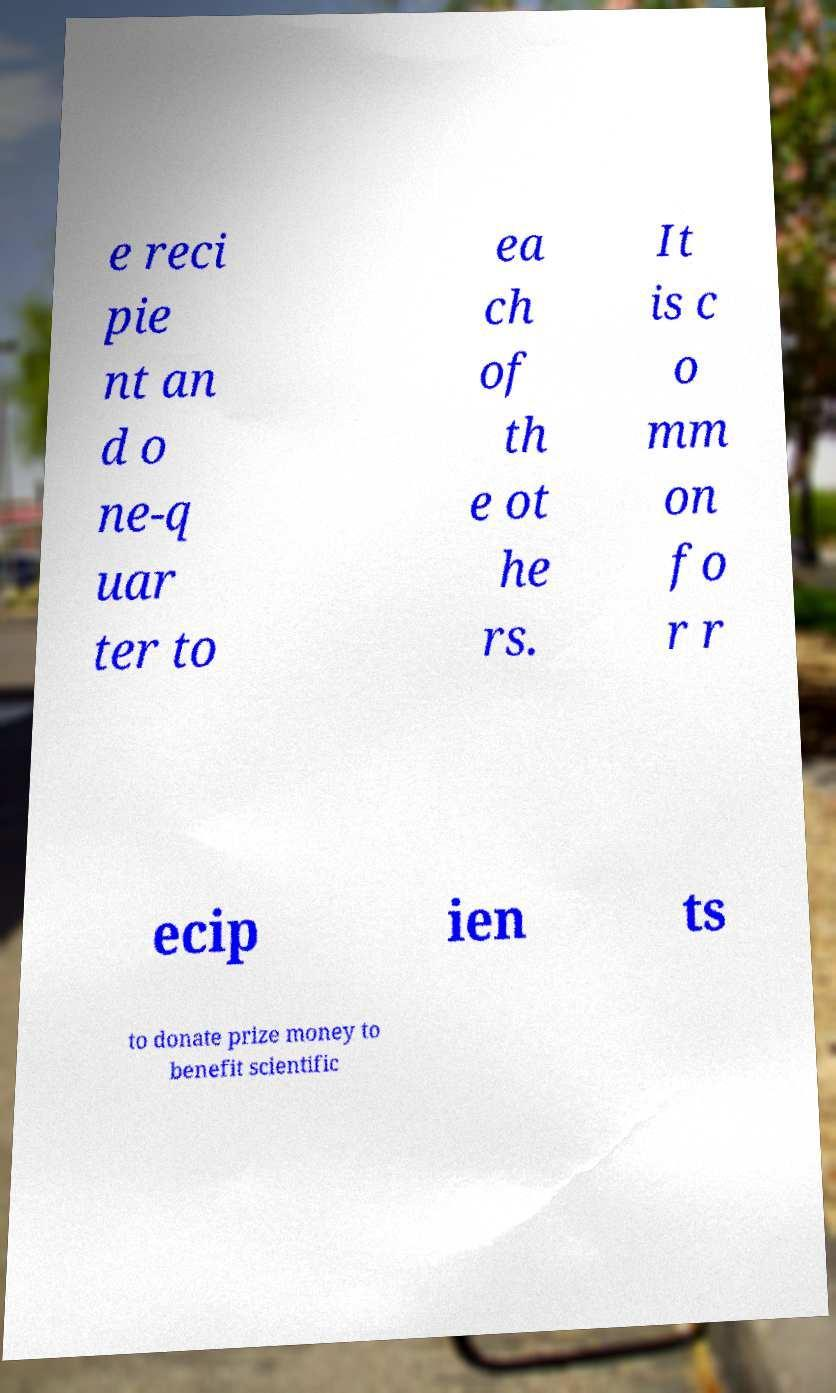Please identify and transcribe the text found in this image. e reci pie nt an d o ne-q uar ter to ea ch of th e ot he rs. It is c o mm on fo r r ecip ien ts to donate prize money to benefit scientific 